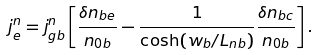<formula> <loc_0><loc_0><loc_500><loc_500>j _ { e } ^ { n } = j _ { g b } ^ { n } \left [ \frac { \delta n _ { b e } } { n _ { 0 b } } - \frac { 1 } { \cosh ( w _ { b } / L _ { n b } ) } \frac { \delta n _ { b c } } { n _ { 0 b } } \right ] .</formula> 